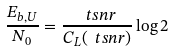Convert formula to latex. <formula><loc_0><loc_0><loc_500><loc_500>\frac { E _ { b , U } } { N _ { 0 } } = \frac { \ t s n r } { C _ { L } ( \ t s n r ) } \log 2</formula> 